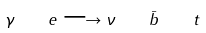Convert formula to latex. <formula><loc_0><loc_0><loc_500><loc_500>\gamma \quad e \longrightarrow \nu \quad \bar { b } \quad t</formula> 